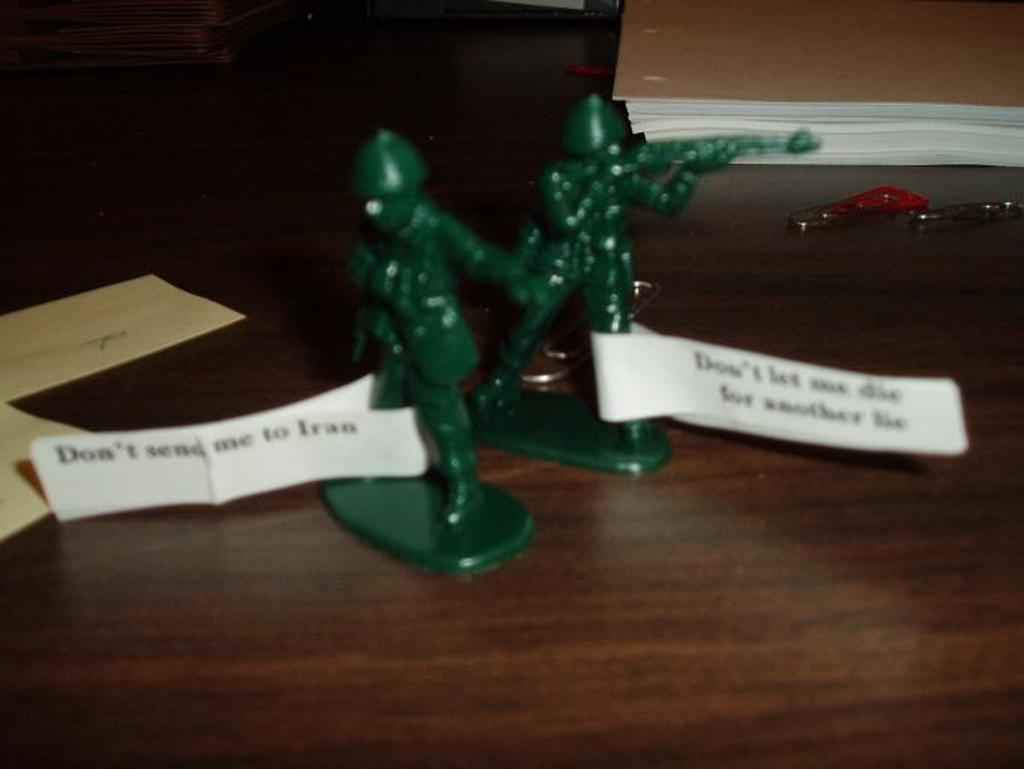Describe this image in one or two sentences. In the foreground of this image, there are two toy statues on a wooden surface and there are paper tags to their legs. We can also see papers, paper clips, wall and an object on the left top. 